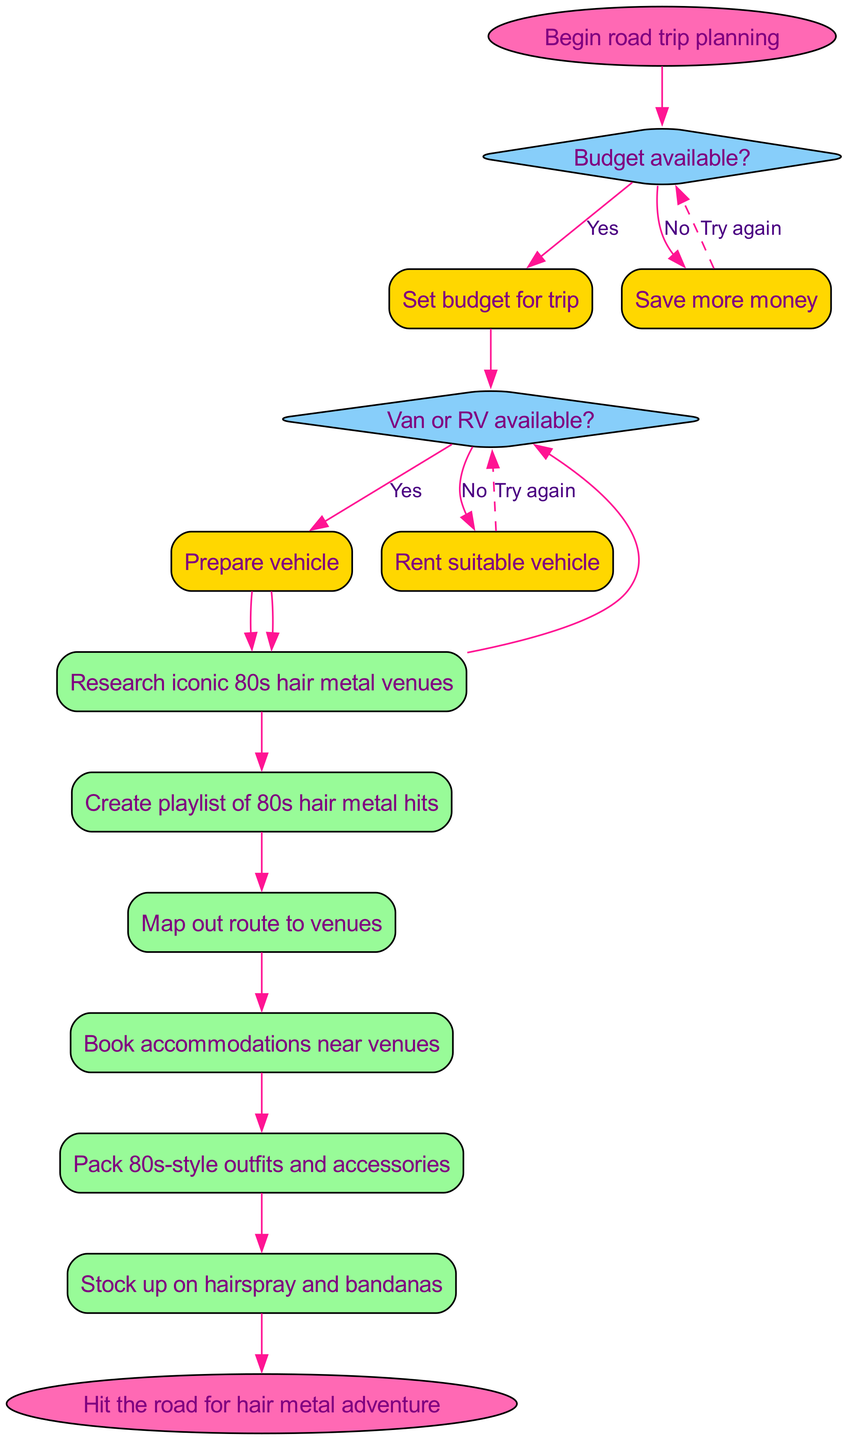What's the starting action in the flow chart? The flow chart begins with the node labeled "Begin road trip planning." This is the first step that initiates the entire process of planning a cross-country road trip.
Answer: Begin road trip planning How many decisions are made in the chart? The flow chart contains two decision nodes that check specific conditions: "Budget available?" and "Van or RV available?" Therefore, the total count of decisions made is two.
Answer: 2 What is the first action taken after the first 'Yes' decision? After the first decision "Budget available?" receives a 'Yes', the next action taken is "Set budget for trip." This indicates that a budget is established as the next step.
Answer: Set budget for trip What happens if the answer to "Van or RV available?" is 'No'? If the answer to "Van or RV available?" is 'No', then the flow directs the user to "Rent suitable vehicle." This indicates that renting a vehicle is necessary if none is available.
Answer: Rent suitable vehicle What is the final action before hitting the road? The final action in the flow chart, just before reaching the end, is "Stock up on hairspray and bandanas." This reflects an essential preparation step right before the journey begins.
Answer: Stock up on hairspray and bandanas After setting the budget, what action follows? Following the action of "Set budget for trip," the next action in the flow is "Research iconic 80s hair metal venues." This means after budgeting, the focus shifts to exploring the venues of interest.
Answer: Research iconic 80s hair metal venues What is the relationship between the second decision and its 'Yes' outcome? The second decision is "Van or RV available?". If the answer is 'Yes', it leads to the action "Prepare vehicle." This highlights the step needed to ensure the vehicle is ready for the trip.
Answer: Prepare vehicle How do you reach the endpoint of the flow chart? To reach the endpoint labeled "Hit the road for hair metal adventure," one must follow the actions sequentially from the last action, which is "Stock up on hairspray and bandanas." This indicates that after completing all necessary preparations, you can finally start your adventure.
Answer: Hit the road for hair metal adventure 